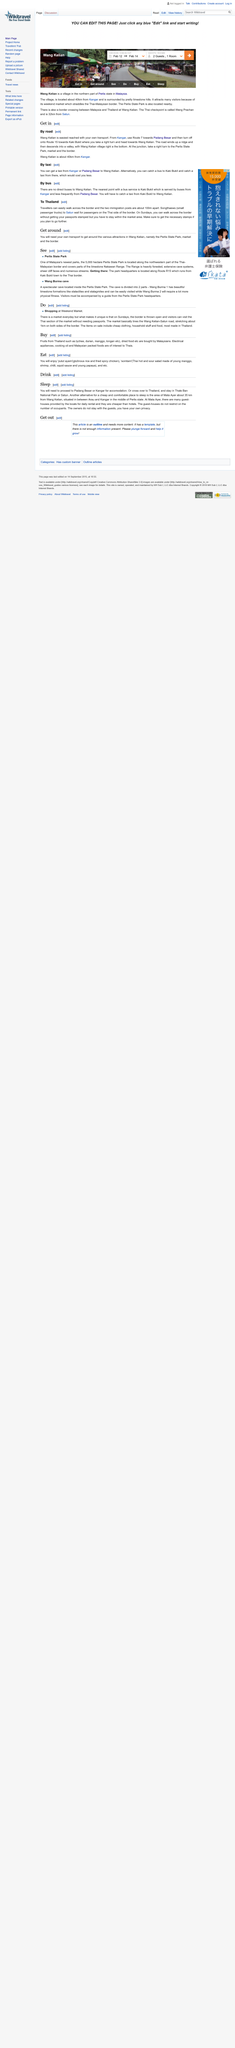Indicate a few pertinent items in this graphic. Wang Kelian, a village located in the northern part of Perlis state in Malaysia, is known for its rich cultural heritage and breathtaking natural beauty. Wang Kelian is located approximately 40 kilometers from the place of Kangar. The article is discussing Perlis State Park. Wang Kelian is surrounded by picturesque limestone hills. The Wang Burma Cave is a two-part cave located in a state park. 